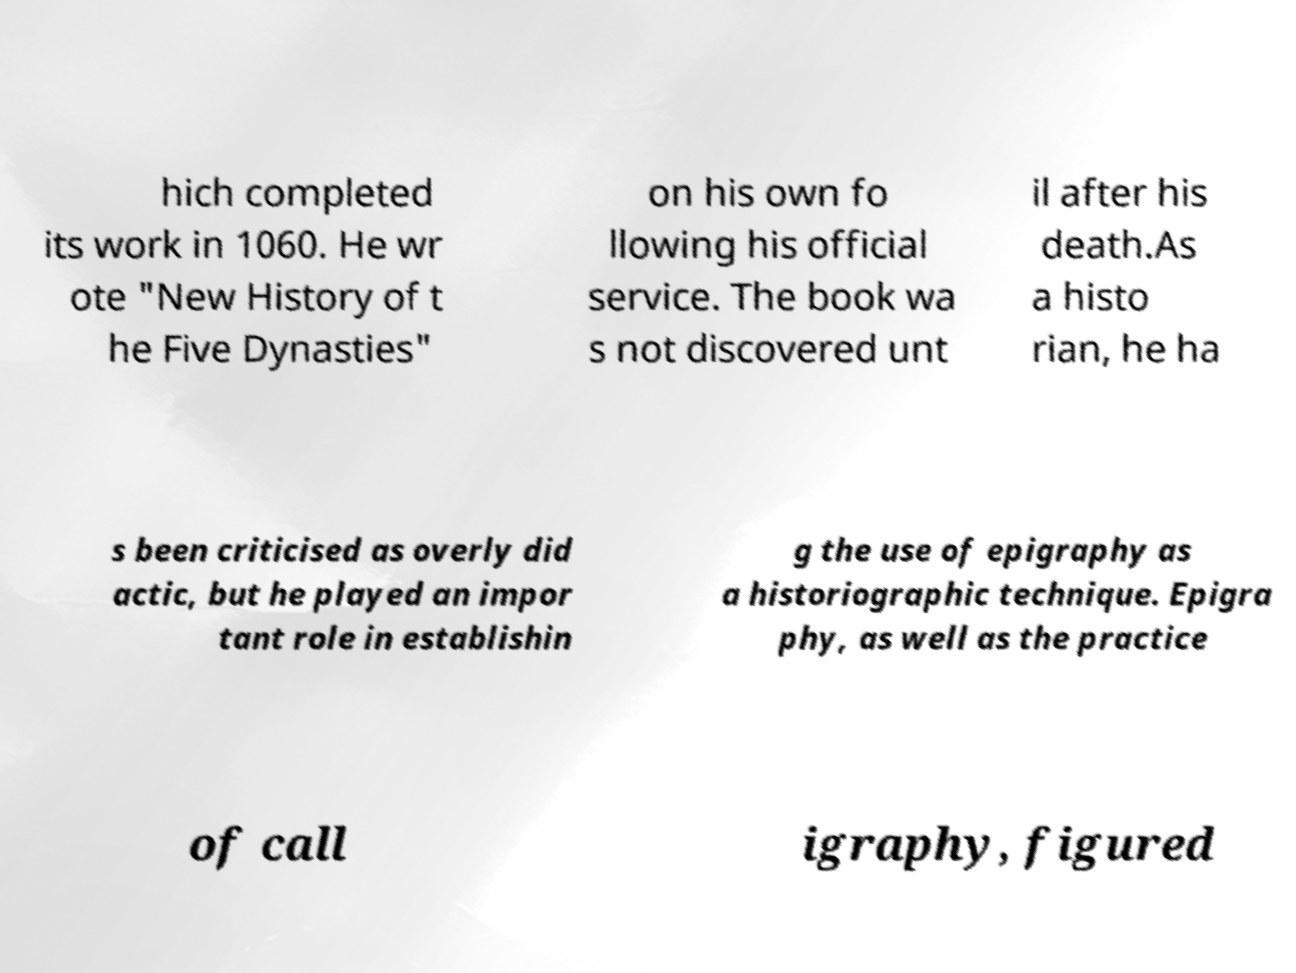Please identify and transcribe the text found in this image. hich completed its work in 1060. He wr ote "New History of t he Five Dynasties" on his own fo llowing his official service. The book wa s not discovered unt il after his death.As a histo rian, he ha s been criticised as overly did actic, but he played an impor tant role in establishin g the use of epigraphy as a historiographic technique. Epigra phy, as well as the practice of call igraphy, figured 